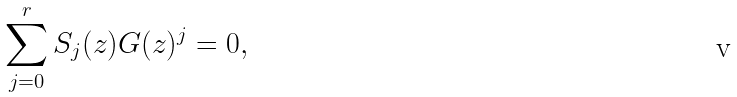<formula> <loc_0><loc_0><loc_500><loc_500>\sum _ { j = 0 } ^ { r } S _ { j } ( z ) G ( z ) ^ { j } = 0 ,</formula> 